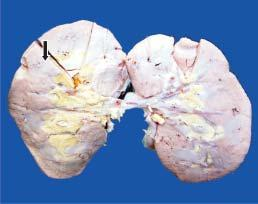how is the kidney?
Answer the question using a single word or phrase. Small and pale in colour 